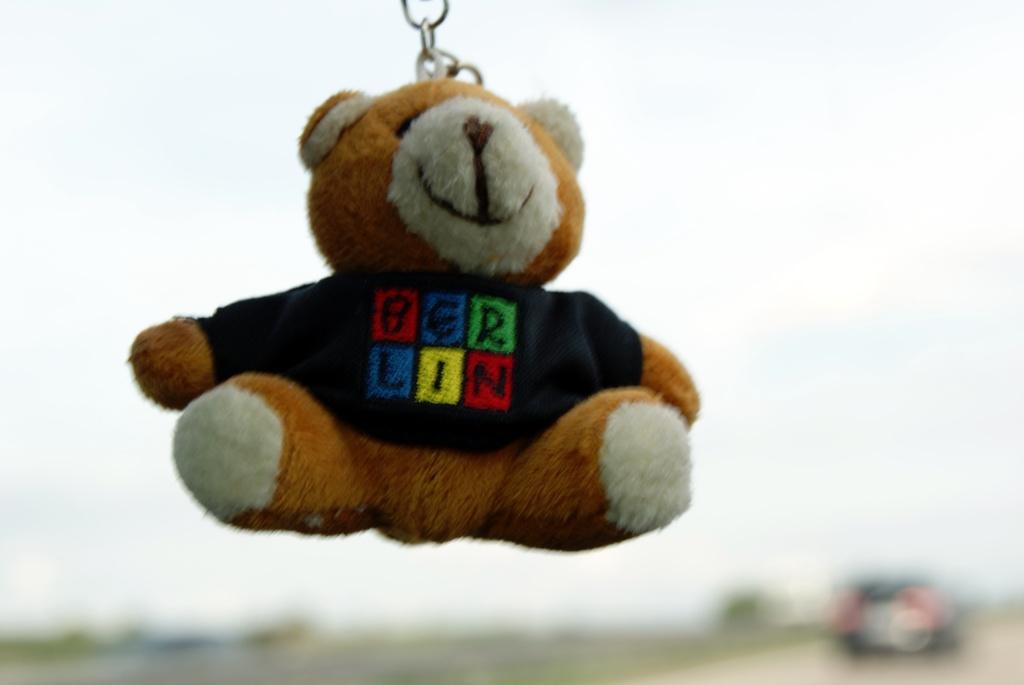Please provide a concise description of this image. In this picture there is a teddy bear and there is text on the teddy bear. At the back there is a vehicle and there are trees. At the top there is sky. At the bottom it looks like a road. 